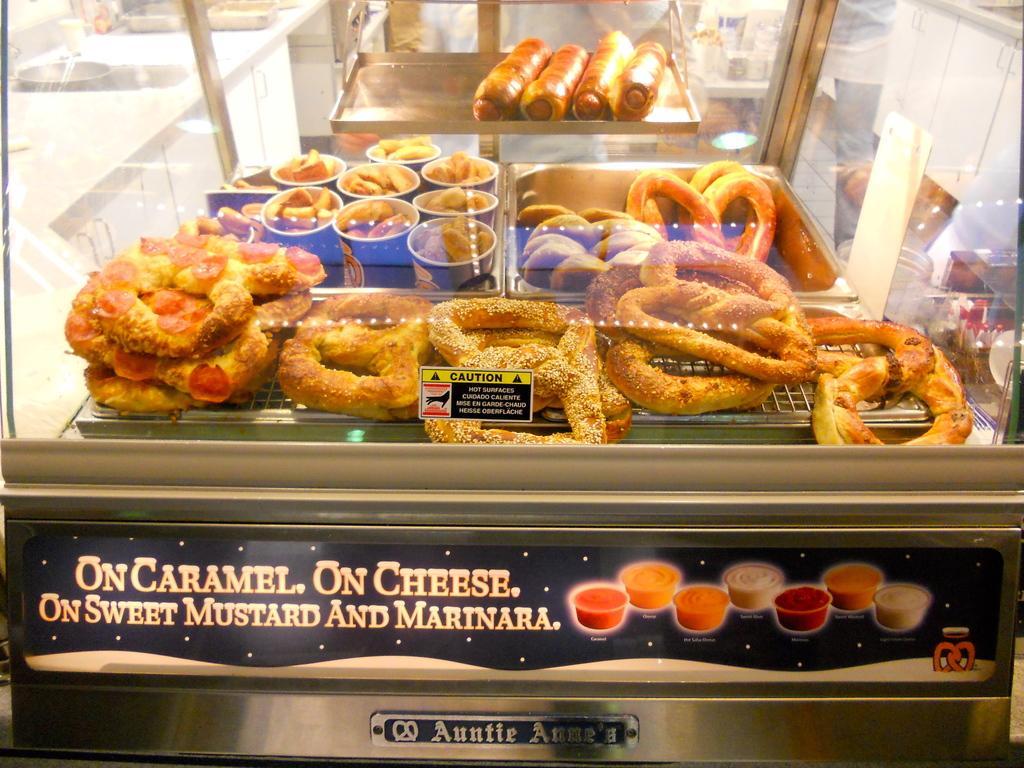How would you summarize this image in a sentence or two? In this picture there is a glass container in the image, in which there are donuts and rolls. 